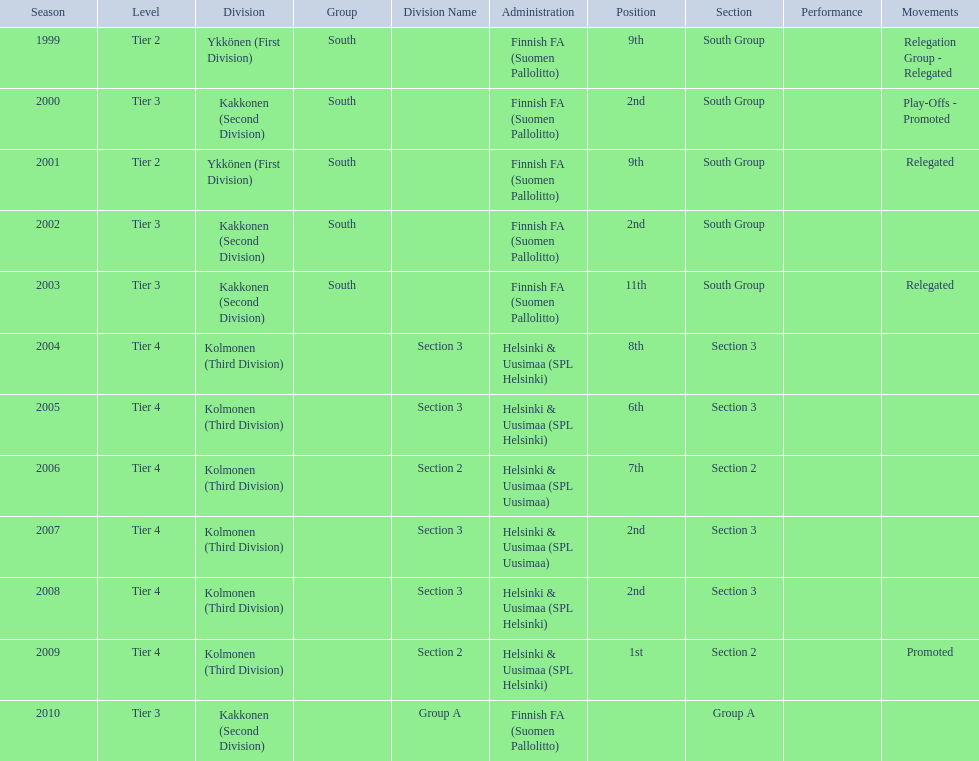How many 2nd positions were there? 4. 